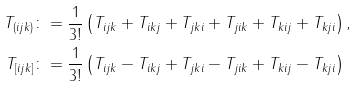Convert formula to latex. <formula><loc_0><loc_0><loc_500><loc_500>T _ { ( i j k ) } & \colon = \frac { 1 } { 3 ! } \left ( T _ { i j k } + T _ { i k j } + T _ { j k i } + T _ { j i k } + T _ { k i j } + T _ { k j i } \right ) , \\ T _ { [ i j k ] } & \colon = \frac { 1 } { 3 ! } \left ( T _ { i j k } - T _ { i k j } + T _ { j k i } - T _ { j i k } + T _ { k i j } - T _ { k j i } \right )</formula> 